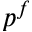<formula> <loc_0><loc_0><loc_500><loc_500>p ^ { f }</formula> 